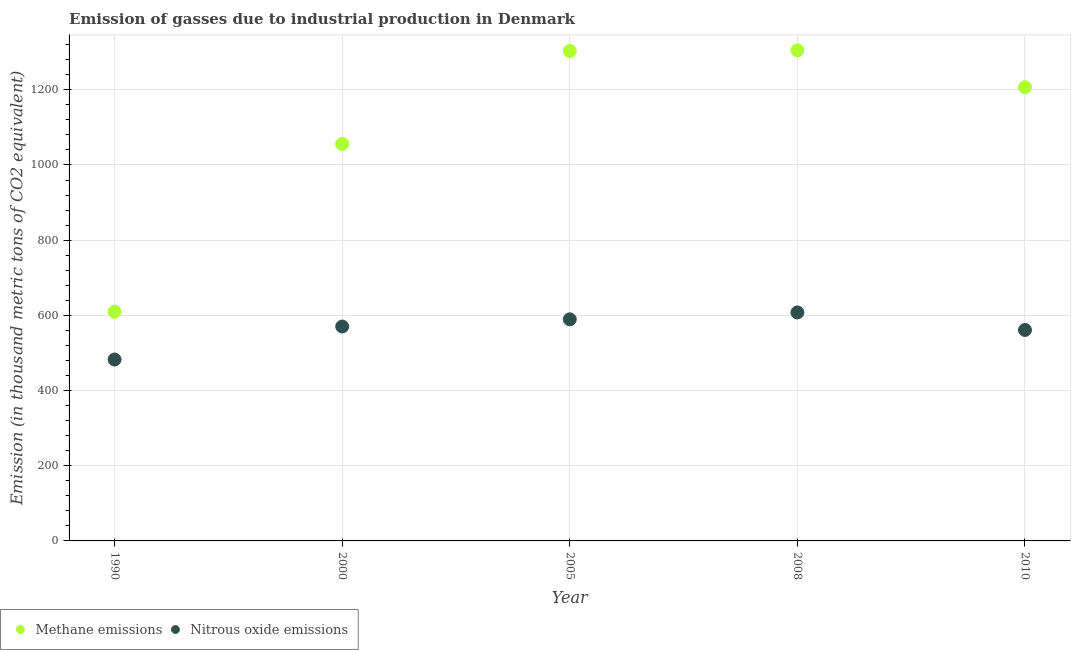How many different coloured dotlines are there?
Your answer should be compact. 2. What is the amount of nitrous oxide emissions in 1990?
Your response must be concise. 482.5. Across all years, what is the maximum amount of methane emissions?
Give a very brief answer. 1304.9. Across all years, what is the minimum amount of methane emissions?
Your answer should be very brief. 609.7. In which year was the amount of nitrous oxide emissions maximum?
Your answer should be very brief. 2008. What is the total amount of methane emissions in the graph?
Provide a succinct answer. 5480.5. What is the difference between the amount of methane emissions in 1990 and that in 2010?
Provide a short and direct response. -597.1. What is the difference between the amount of methane emissions in 1990 and the amount of nitrous oxide emissions in 2000?
Provide a short and direct response. 39.4. What is the average amount of methane emissions per year?
Offer a very short reply. 1096.1. In the year 2010, what is the difference between the amount of nitrous oxide emissions and amount of methane emissions?
Your answer should be compact. -645.7. What is the ratio of the amount of methane emissions in 2005 to that in 2010?
Provide a short and direct response. 1.08. Is the difference between the amount of nitrous oxide emissions in 2005 and 2010 greater than the difference between the amount of methane emissions in 2005 and 2010?
Provide a succinct answer. No. What is the difference between the highest and the second highest amount of methane emissions?
Offer a very short reply. 1.8. What is the difference between the highest and the lowest amount of nitrous oxide emissions?
Offer a very short reply. 125.3. In how many years, is the amount of methane emissions greater than the average amount of methane emissions taken over all years?
Ensure brevity in your answer.  3. Does the amount of nitrous oxide emissions monotonically increase over the years?
Your response must be concise. No. How many years are there in the graph?
Offer a very short reply. 5. Are the values on the major ticks of Y-axis written in scientific E-notation?
Keep it short and to the point. No. Does the graph contain any zero values?
Provide a succinct answer. No. How many legend labels are there?
Offer a very short reply. 2. How are the legend labels stacked?
Offer a terse response. Horizontal. What is the title of the graph?
Ensure brevity in your answer.  Emission of gasses due to industrial production in Denmark. What is the label or title of the X-axis?
Offer a very short reply. Year. What is the label or title of the Y-axis?
Your response must be concise. Emission (in thousand metric tons of CO2 equivalent). What is the Emission (in thousand metric tons of CO2 equivalent) in Methane emissions in 1990?
Your answer should be compact. 609.7. What is the Emission (in thousand metric tons of CO2 equivalent) in Nitrous oxide emissions in 1990?
Make the answer very short. 482.5. What is the Emission (in thousand metric tons of CO2 equivalent) in Methane emissions in 2000?
Your answer should be compact. 1056. What is the Emission (in thousand metric tons of CO2 equivalent) of Nitrous oxide emissions in 2000?
Your answer should be very brief. 570.3. What is the Emission (in thousand metric tons of CO2 equivalent) in Methane emissions in 2005?
Your answer should be compact. 1303.1. What is the Emission (in thousand metric tons of CO2 equivalent) in Nitrous oxide emissions in 2005?
Ensure brevity in your answer.  589.4. What is the Emission (in thousand metric tons of CO2 equivalent) in Methane emissions in 2008?
Your answer should be very brief. 1304.9. What is the Emission (in thousand metric tons of CO2 equivalent) in Nitrous oxide emissions in 2008?
Offer a very short reply. 607.8. What is the Emission (in thousand metric tons of CO2 equivalent) of Methane emissions in 2010?
Your answer should be very brief. 1206.8. What is the Emission (in thousand metric tons of CO2 equivalent) of Nitrous oxide emissions in 2010?
Your answer should be very brief. 561.1. Across all years, what is the maximum Emission (in thousand metric tons of CO2 equivalent) of Methane emissions?
Give a very brief answer. 1304.9. Across all years, what is the maximum Emission (in thousand metric tons of CO2 equivalent) in Nitrous oxide emissions?
Offer a very short reply. 607.8. Across all years, what is the minimum Emission (in thousand metric tons of CO2 equivalent) in Methane emissions?
Ensure brevity in your answer.  609.7. Across all years, what is the minimum Emission (in thousand metric tons of CO2 equivalent) in Nitrous oxide emissions?
Keep it short and to the point. 482.5. What is the total Emission (in thousand metric tons of CO2 equivalent) of Methane emissions in the graph?
Give a very brief answer. 5480.5. What is the total Emission (in thousand metric tons of CO2 equivalent) of Nitrous oxide emissions in the graph?
Make the answer very short. 2811.1. What is the difference between the Emission (in thousand metric tons of CO2 equivalent) in Methane emissions in 1990 and that in 2000?
Make the answer very short. -446.3. What is the difference between the Emission (in thousand metric tons of CO2 equivalent) of Nitrous oxide emissions in 1990 and that in 2000?
Make the answer very short. -87.8. What is the difference between the Emission (in thousand metric tons of CO2 equivalent) in Methane emissions in 1990 and that in 2005?
Provide a succinct answer. -693.4. What is the difference between the Emission (in thousand metric tons of CO2 equivalent) in Nitrous oxide emissions in 1990 and that in 2005?
Your answer should be compact. -106.9. What is the difference between the Emission (in thousand metric tons of CO2 equivalent) of Methane emissions in 1990 and that in 2008?
Keep it short and to the point. -695.2. What is the difference between the Emission (in thousand metric tons of CO2 equivalent) in Nitrous oxide emissions in 1990 and that in 2008?
Provide a short and direct response. -125.3. What is the difference between the Emission (in thousand metric tons of CO2 equivalent) in Methane emissions in 1990 and that in 2010?
Your answer should be very brief. -597.1. What is the difference between the Emission (in thousand metric tons of CO2 equivalent) in Nitrous oxide emissions in 1990 and that in 2010?
Keep it short and to the point. -78.6. What is the difference between the Emission (in thousand metric tons of CO2 equivalent) in Methane emissions in 2000 and that in 2005?
Offer a very short reply. -247.1. What is the difference between the Emission (in thousand metric tons of CO2 equivalent) of Nitrous oxide emissions in 2000 and that in 2005?
Give a very brief answer. -19.1. What is the difference between the Emission (in thousand metric tons of CO2 equivalent) of Methane emissions in 2000 and that in 2008?
Offer a terse response. -248.9. What is the difference between the Emission (in thousand metric tons of CO2 equivalent) of Nitrous oxide emissions in 2000 and that in 2008?
Provide a succinct answer. -37.5. What is the difference between the Emission (in thousand metric tons of CO2 equivalent) in Methane emissions in 2000 and that in 2010?
Provide a short and direct response. -150.8. What is the difference between the Emission (in thousand metric tons of CO2 equivalent) of Methane emissions in 2005 and that in 2008?
Make the answer very short. -1.8. What is the difference between the Emission (in thousand metric tons of CO2 equivalent) in Nitrous oxide emissions in 2005 and that in 2008?
Provide a short and direct response. -18.4. What is the difference between the Emission (in thousand metric tons of CO2 equivalent) in Methane emissions in 2005 and that in 2010?
Provide a succinct answer. 96.3. What is the difference between the Emission (in thousand metric tons of CO2 equivalent) of Nitrous oxide emissions in 2005 and that in 2010?
Provide a succinct answer. 28.3. What is the difference between the Emission (in thousand metric tons of CO2 equivalent) of Methane emissions in 2008 and that in 2010?
Ensure brevity in your answer.  98.1. What is the difference between the Emission (in thousand metric tons of CO2 equivalent) of Nitrous oxide emissions in 2008 and that in 2010?
Give a very brief answer. 46.7. What is the difference between the Emission (in thousand metric tons of CO2 equivalent) of Methane emissions in 1990 and the Emission (in thousand metric tons of CO2 equivalent) of Nitrous oxide emissions in 2000?
Offer a very short reply. 39.4. What is the difference between the Emission (in thousand metric tons of CO2 equivalent) of Methane emissions in 1990 and the Emission (in thousand metric tons of CO2 equivalent) of Nitrous oxide emissions in 2005?
Provide a succinct answer. 20.3. What is the difference between the Emission (in thousand metric tons of CO2 equivalent) in Methane emissions in 1990 and the Emission (in thousand metric tons of CO2 equivalent) in Nitrous oxide emissions in 2010?
Offer a very short reply. 48.6. What is the difference between the Emission (in thousand metric tons of CO2 equivalent) in Methane emissions in 2000 and the Emission (in thousand metric tons of CO2 equivalent) in Nitrous oxide emissions in 2005?
Keep it short and to the point. 466.6. What is the difference between the Emission (in thousand metric tons of CO2 equivalent) of Methane emissions in 2000 and the Emission (in thousand metric tons of CO2 equivalent) of Nitrous oxide emissions in 2008?
Offer a terse response. 448.2. What is the difference between the Emission (in thousand metric tons of CO2 equivalent) in Methane emissions in 2000 and the Emission (in thousand metric tons of CO2 equivalent) in Nitrous oxide emissions in 2010?
Provide a succinct answer. 494.9. What is the difference between the Emission (in thousand metric tons of CO2 equivalent) of Methane emissions in 2005 and the Emission (in thousand metric tons of CO2 equivalent) of Nitrous oxide emissions in 2008?
Give a very brief answer. 695.3. What is the difference between the Emission (in thousand metric tons of CO2 equivalent) of Methane emissions in 2005 and the Emission (in thousand metric tons of CO2 equivalent) of Nitrous oxide emissions in 2010?
Your answer should be very brief. 742. What is the difference between the Emission (in thousand metric tons of CO2 equivalent) in Methane emissions in 2008 and the Emission (in thousand metric tons of CO2 equivalent) in Nitrous oxide emissions in 2010?
Provide a short and direct response. 743.8. What is the average Emission (in thousand metric tons of CO2 equivalent) in Methane emissions per year?
Your answer should be very brief. 1096.1. What is the average Emission (in thousand metric tons of CO2 equivalent) of Nitrous oxide emissions per year?
Your answer should be very brief. 562.22. In the year 1990, what is the difference between the Emission (in thousand metric tons of CO2 equivalent) in Methane emissions and Emission (in thousand metric tons of CO2 equivalent) in Nitrous oxide emissions?
Offer a terse response. 127.2. In the year 2000, what is the difference between the Emission (in thousand metric tons of CO2 equivalent) of Methane emissions and Emission (in thousand metric tons of CO2 equivalent) of Nitrous oxide emissions?
Ensure brevity in your answer.  485.7. In the year 2005, what is the difference between the Emission (in thousand metric tons of CO2 equivalent) in Methane emissions and Emission (in thousand metric tons of CO2 equivalent) in Nitrous oxide emissions?
Make the answer very short. 713.7. In the year 2008, what is the difference between the Emission (in thousand metric tons of CO2 equivalent) in Methane emissions and Emission (in thousand metric tons of CO2 equivalent) in Nitrous oxide emissions?
Provide a succinct answer. 697.1. In the year 2010, what is the difference between the Emission (in thousand metric tons of CO2 equivalent) of Methane emissions and Emission (in thousand metric tons of CO2 equivalent) of Nitrous oxide emissions?
Provide a short and direct response. 645.7. What is the ratio of the Emission (in thousand metric tons of CO2 equivalent) of Methane emissions in 1990 to that in 2000?
Your response must be concise. 0.58. What is the ratio of the Emission (in thousand metric tons of CO2 equivalent) in Nitrous oxide emissions in 1990 to that in 2000?
Offer a terse response. 0.85. What is the ratio of the Emission (in thousand metric tons of CO2 equivalent) in Methane emissions in 1990 to that in 2005?
Ensure brevity in your answer.  0.47. What is the ratio of the Emission (in thousand metric tons of CO2 equivalent) of Nitrous oxide emissions in 1990 to that in 2005?
Provide a short and direct response. 0.82. What is the ratio of the Emission (in thousand metric tons of CO2 equivalent) of Methane emissions in 1990 to that in 2008?
Ensure brevity in your answer.  0.47. What is the ratio of the Emission (in thousand metric tons of CO2 equivalent) of Nitrous oxide emissions in 1990 to that in 2008?
Provide a succinct answer. 0.79. What is the ratio of the Emission (in thousand metric tons of CO2 equivalent) of Methane emissions in 1990 to that in 2010?
Your answer should be compact. 0.51. What is the ratio of the Emission (in thousand metric tons of CO2 equivalent) in Nitrous oxide emissions in 1990 to that in 2010?
Provide a short and direct response. 0.86. What is the ratio of the Emission (in thousand metric tons of CO2 equivalent) in Methane emissions in 2000 to that in 2005?
Your answer should be very brief. 0.81. What is the ratio of the Emission (in thousand metric tons of CO2 equivalent) in Nitrous oxide emissions in 2000 to that in 2005?
Give a very brief answer. 0.97. What is the ratio of the Emission (in thousand metric tons of CO2 equivalent) of Methane emissions in 2000 to that in 2008?
Provide a succinct answer. 0.81. What is the ratio of the Emission (in thousand metric tons of CO2 equivalent) in Nitrous oxide emissions in 2000 to that in 2008?
Offer a very short reply. 0.94. What is the ratio of the Emission (in thousand metric tons of CO2 equivalent) in Methane emissions in 2000 to that in 2010?
Ensure brevity in your answer.  0.88. What is the ratio of the Emission (in thousand metric tons of CO2 equivalent) in Nitrous oxide emissions in 2000 to that in 2010?
Your answer should be very brief. 1.02. What is the ratio of the Emission (in thousand metric tons of CO2 equivalent) of Nitrous oxide emissions in 2005 to that in 2008?
Give a very brief answer. 0.97. What is the ratio of the Emission (in thousand metric tons of CO2 equivalent) in Methane emissions in 2005 to that in 2010?
Keep it short and to the point. 1.08. What is the ratio of the Emission (in thousand metric tons of CO2 equivalent) of Nitrous oxide emissions in 2005 to that in 2010?
Your answer should be compact. 1.05. What is the ratio of the Emission (in thousand metric tons of CO2 equivalent) in Methane emissions in 2008 to that in 2010?
Make the answer very short. 1.08. What is the ratio of the Emission (in thousand metric tons of CO2 equivalent) of Nitrous oxide emissions in 2008 to that in 2010?
Your answer should be very brief. 1.08. What is the difference between the highest and the lowest Emission (in thousand metric tons of CO2 equivalent) in Methane emissions?
Provide a succinct answer. 695.2. What is the difference between the highest and the lowest Emission (in thousand metric tons of CO2 equivalent) of Nitrous oxide emissions?
Keep it short and to the point. 125.3. 